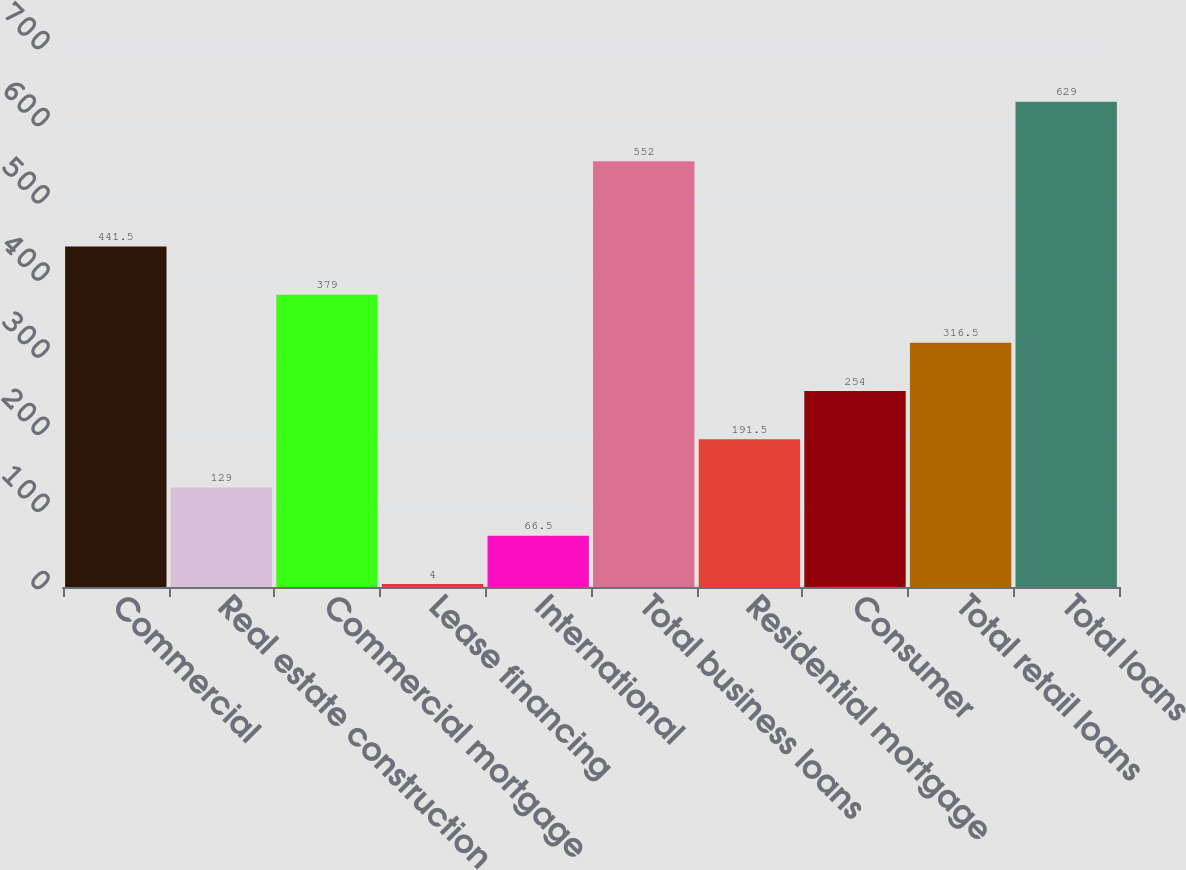Convert chart to OTSL. <chart><loc_0><loc_0><loc_500><loc_500><bar_chart><fcel>Commercial<fcel>Real estate construction<fcel>Commercial mortgage<fcel>Lease financing<fcel>International<fcel>Total business loans<fcel>Residential mortgage<fcel>Consumer<fcel>Total retail loans<fcel>Total loans<nl><fcel>441.5<fcel>129<fcel>379<fcel>4<fcel>66.5<fcel>552<fcel>191.5<fcel>254<fcel>316.5<fcel>629<nl></chart> 